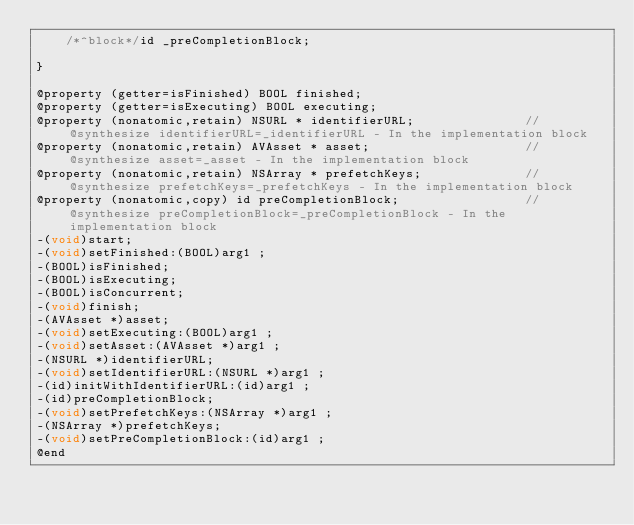<code> <loc_0><loc_0><loc_500><loc_500><_C_>	/*^block*/id _preCompletionBlock;

}

@property (getter=isFinished) BOOL finished; 
@property (getter=isExecuting) BOOL executing; 
@property (nonatomic,retain) NSURL * identifierURL;               //@synthesize identifierURL=_identifierURL - In the implementation block
@property (nonatomic,retain) AVAsset * asset;                     //@synthesize asset=_asset - In the implementation block
@property (nonatomic,retain) NSArray * prefetchKeys;              //@synthesize prefetchKeys=_prefetchKeys - In the implementation block
@property (nonatomic,copy) id preCompletionBlock;                 //@synthesize preCompletionBlock=_preCompletionBlock - In the implementation block
-(void)start;
-(void)setFinished:(BOOL)arg1 ;
-(BOOL)isFinished;
-(BOOL)isExecuting;
-(BOOL)isConcurrent;
-(void)finish;
-(AVAsset *)asset;
-(void)setExecuting:(BOOL)arg1 ;
-(void)setAsset:(AVAsset *)arg1 ;
-(NSURL *)identifierURL;
-(void)setIdentifierURL:(NSURL *)arg1 ;
-(id)initWithIdentifierURL:(id)arg1 ;
-(id)preCompletionBlock;
-(void)setPrefetchKeys:(NSArray *)arg1 ;
-(NSArray *)prefetchKeys;
-(void)setPreCompletionBlock:(id)arg1 ;
@end

</code> 